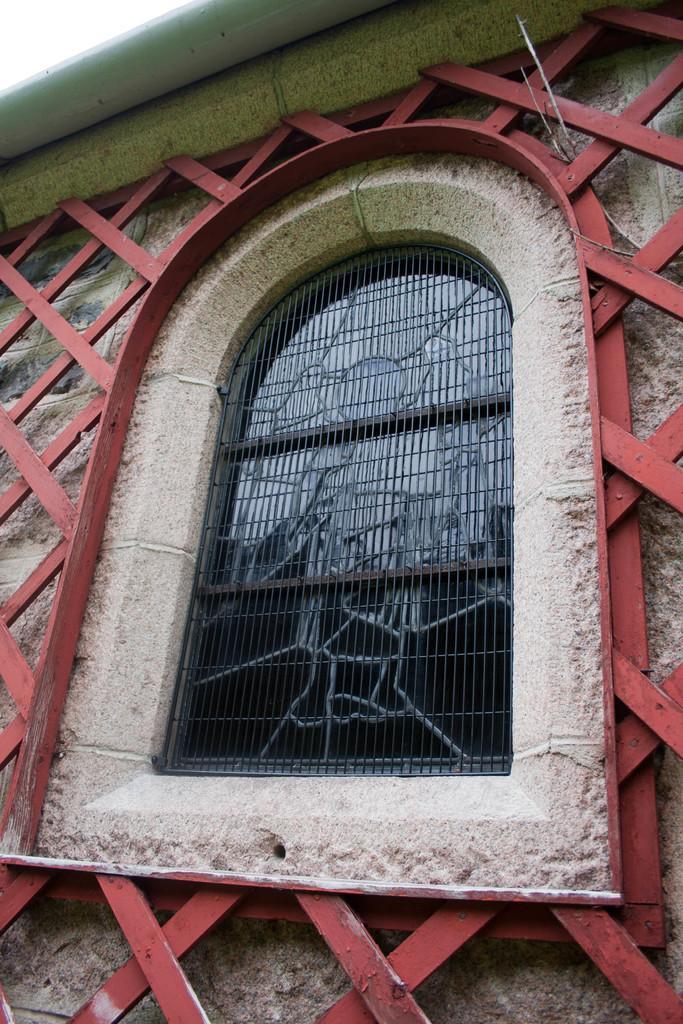In one or two sentences, can you explain what this image depicts? This image is taken outdoors. In this image there is a wall with a window and a few grills on it. 